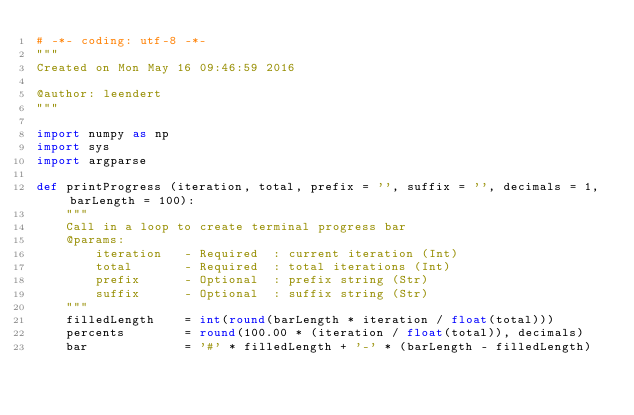<code> <loc_0><loc_0><loc_500><loc_500><_Python_># -*- coding: utf-8 -*-
"""
Created on Mon May 16 09:46:59 2016

@author: leendert
"""

import numpy as np
import sys
import argparse

def printProgress (iteration, total, prefix = '', suffix = '', decimals = 1, barLength = 100):
    """
    Call in a loop to create terminal progress bar
    @params:
        iteration   - Required  : current iteration (Int)
        total       - Required  : total iterations (Int)
        prefix      - Optional  : prefix string (Str)
        suffix      - Optional  : suffix string (Str)
    """
    filledLength    = int(round(barLength * iteration / float(total)))
    percents        = round(100.00 * (iteration / float(total)), decimals)
    bar             = '#' * filledLength + '-' * (barLength - filledLength)</code> 